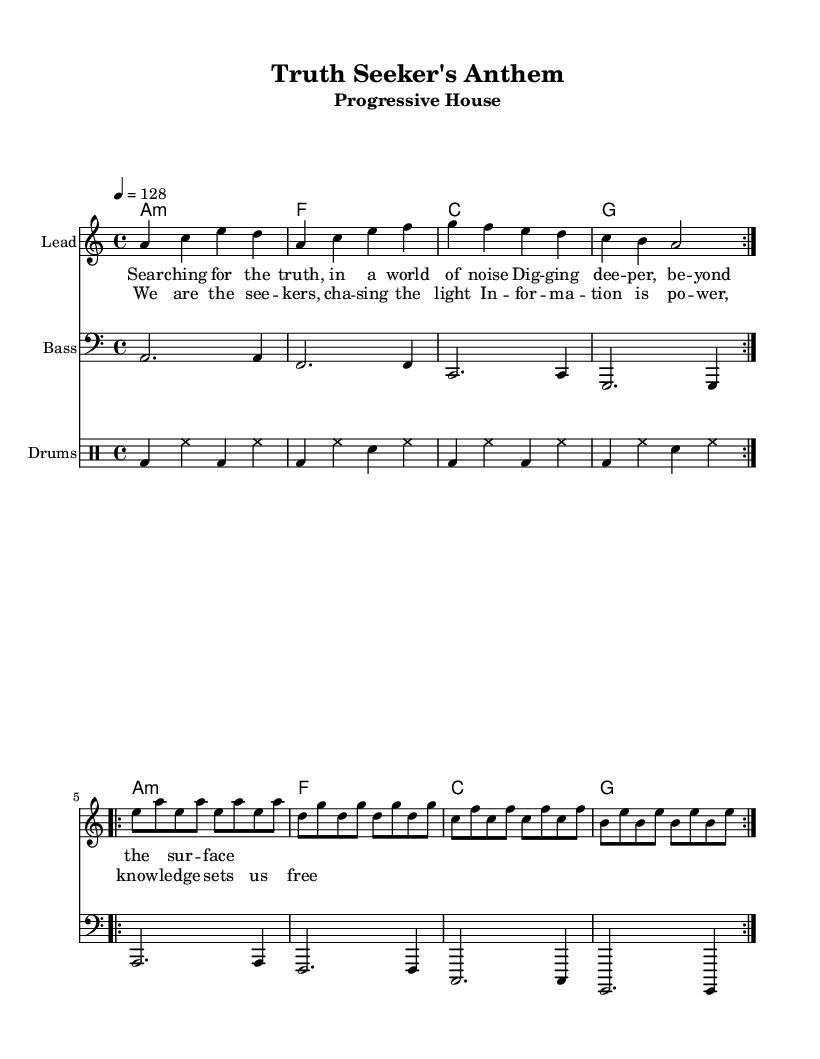What is the key signature of this music? The key signature is A minor, which has no sharps or flats, and is indicated by the absence of any sharps or flats in the appropriate staff lines.
Answer: A minor What is the time signature of this piece? The time signature is indicated at the beginning of the score and is written as 4/4, meaning there are four beats in a measure and the quarter note gets one beat.
Answer: 4/4 What is the tempo marking of this score? The tempo marking shows that the piece is to be played at a tempo of 128 beats per minute, which is indicated by the tempo notation "4 = 128."
Answer: 128 How many repetitions of the melody are indicated? The melody section has a repeat marking, indicated by "repeat volta 2," meaning that the melody is intended to be played two times in total.
Answer: 2 What type of chords are used in the harmony section? The harmony section primarily consists of minor and major chords as indicated by "a1:m" for the A minor chord and the lack of any additional specifics noted in the chord names.
Answer: Minor and major What is the main theme of the lyrics in the verse? The theme expressed in the verse centers around seeking truth amidst noise, emphasizing a journey of deeper understanding beyond superficiality as highlighted by the words "searching for the truth."
Answer: Seeking truth How is the bassline structured throughout the piece? The bassline is consistent and follows a repetitive pattern as seen in the notated measures, where each measure features similar rhythmic content and pitches associated with the respective chords indicated in the harmony.
Answer: Repetitive pattern 